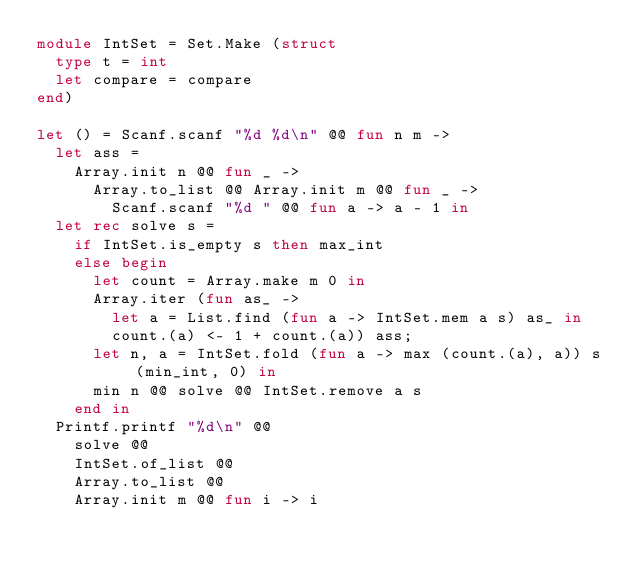Convert code to text. <code><loc_0><loc_0><loc_500><loc_500><_OCaml_>module IntSet = Set.Make (struct
  type t = int
  let compare = compare
end)

let () = Scanf.scanf "%d %d\n" @@ fun n m ->
  let ass =
    Array.init n @@ fun _ ->
      Array.to_list @@ Array.init m @@ fun _ ->
        Scanf.scanf "%d " @@ fun a -> a - 1 in
  let rec solve s =
    if IntSet.is_empty s then max_int
    else begin
      let count = Array.make m 0 in
      Array.iter (fun as_ ->
        let a = List.find (fun a -> IntSet.mem a s) as_ in
        count.(a) <- 1 + count.(a)) ass;
      let n, a = IntSet.fold (fun a -> max (count.(a), a)) s (min_int, 0) in
      min n @@ solve @@ IntSet.remove a s
    end in
  Printf.printf "%d\n" @@
    solve @@
    IntSet.of_list @@
    Array.to_list @@
    Array.init m @@ fun i -> i
</code> 